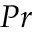<formula> <loc_0><loc_0><loc_500><loc_500>P r</formula> 